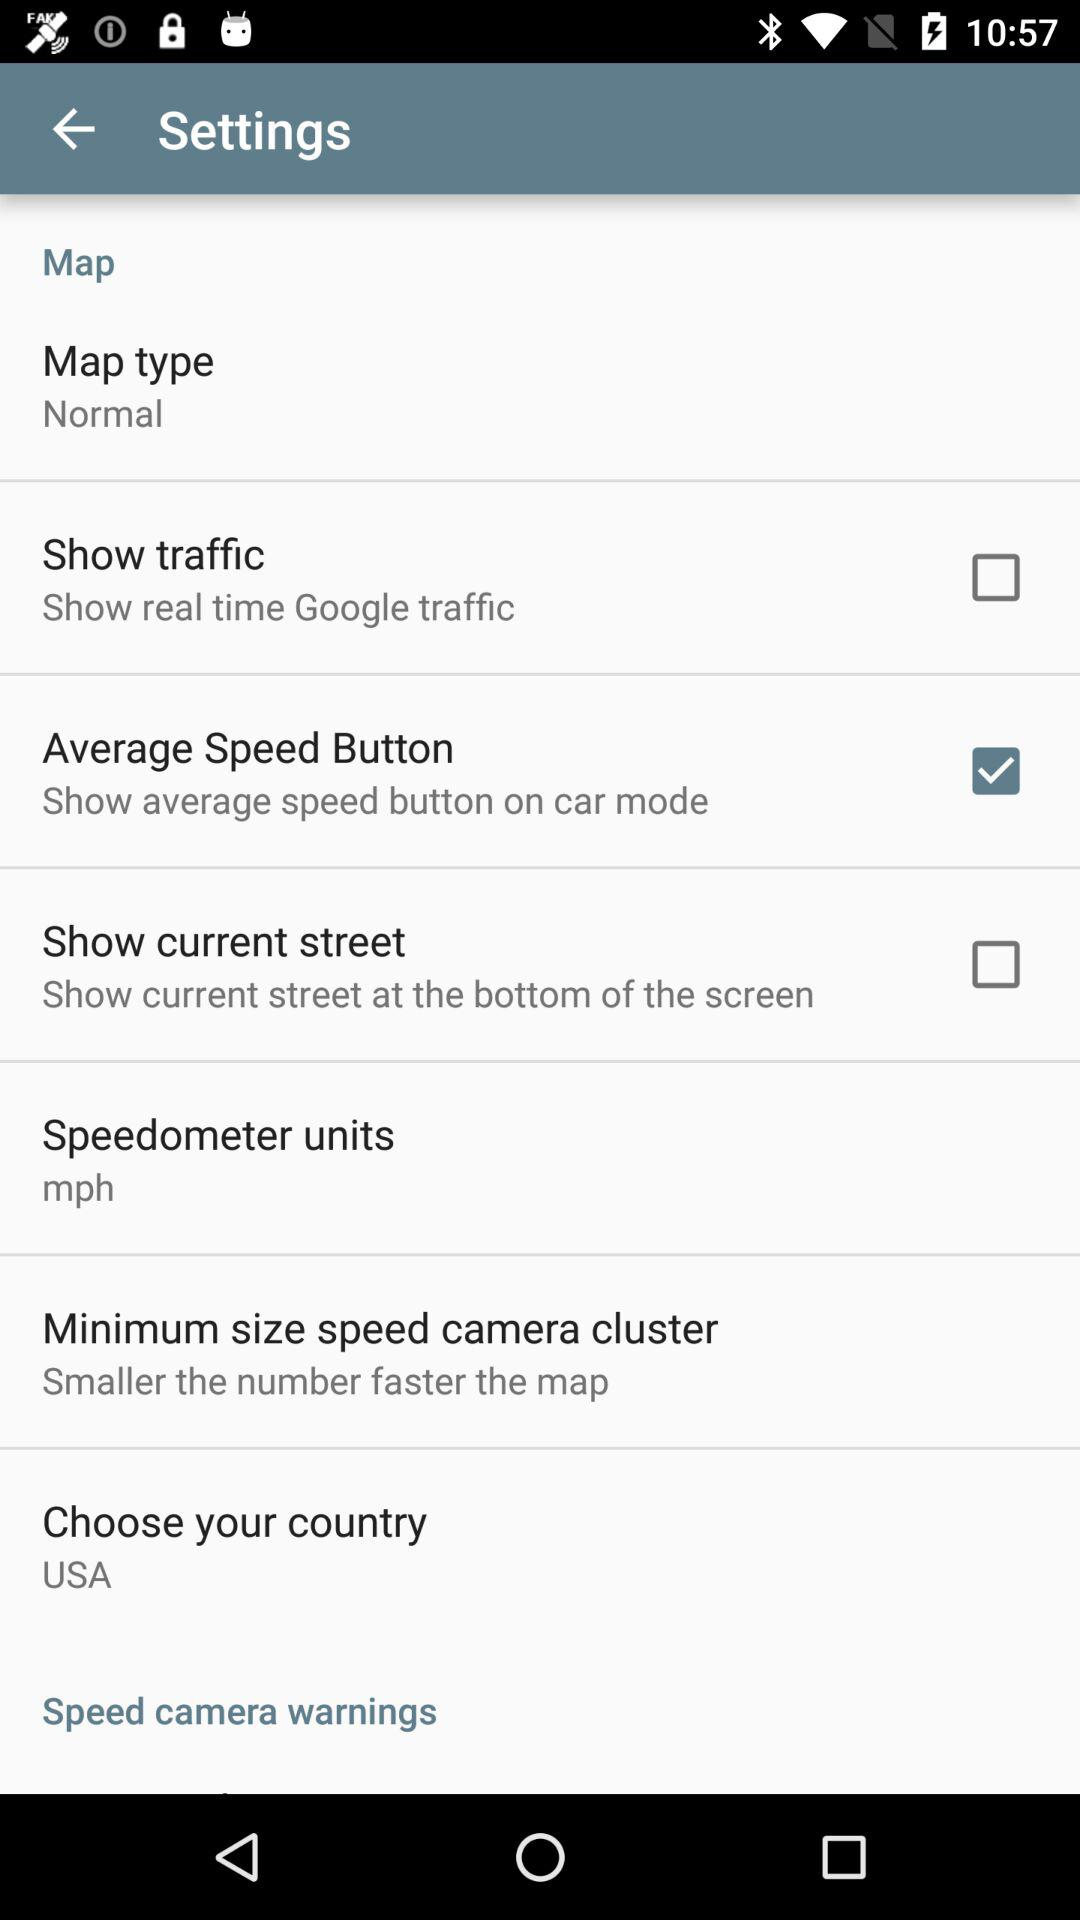What's the map type? The map type is "Normal". 